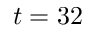Convert formula to latex. <formula><loc_0><loc_0><loc_500><loc_500>t = 3 2</formula> 